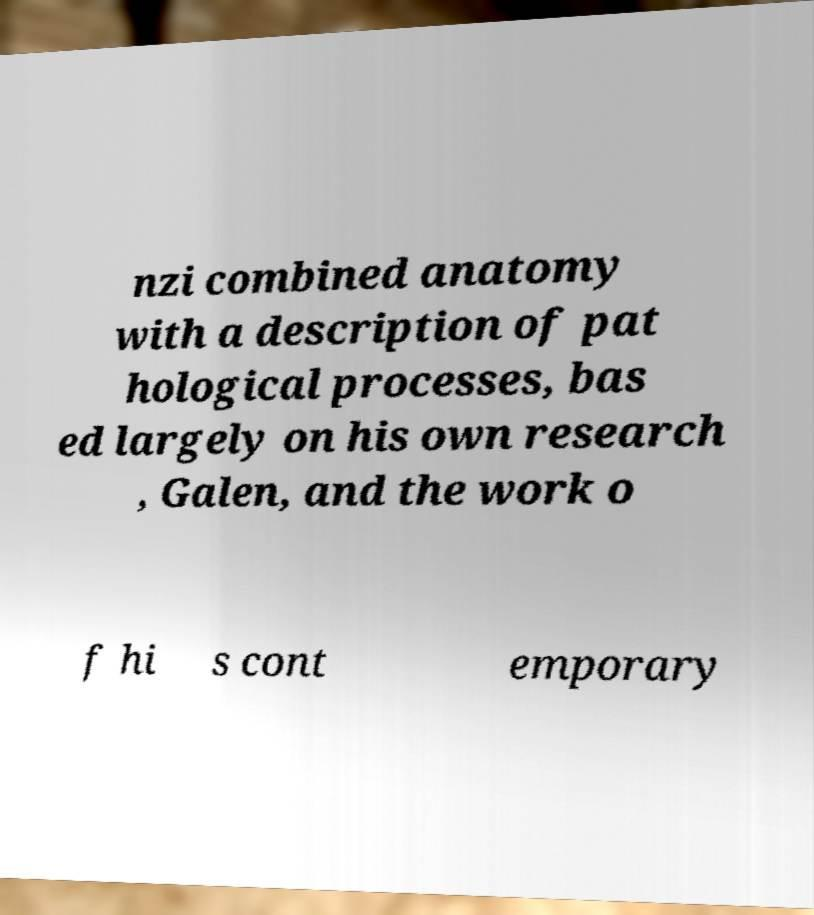Can you read and provide the text displayed in the image?This photo seems to have some interesting text. Can you extract and type it out for me? nzi combined anatomy with a description of pat hological processes, bas ed largely on his own research , Galen, and the work o f hi s cont emporary 